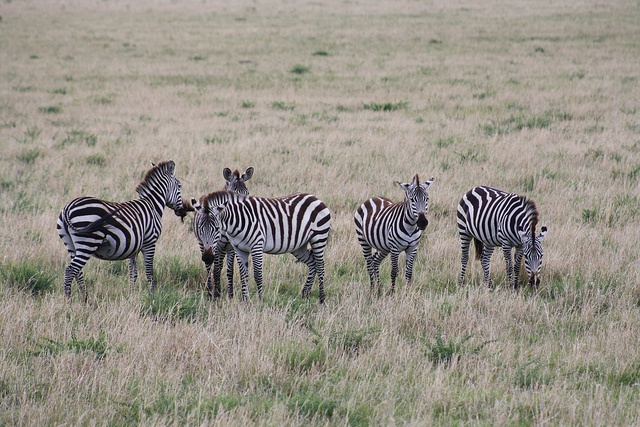Describe the objects in this image and their specific colors. I can see zebra in darkgray, black, gray, and lavender tones, zebra in darkgray, black, gray, and navy tones, zebra in darkgray, black, gray, and lavender tones, zebra in darkgray, black, gray, and lavender tones, and zebra in darkgray, black, and gray tones in this image. 